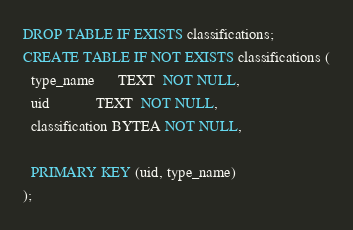<code> <loc_0><loc_0><loc_500><loc_500><_SQL_>DROP TABLE IF EXISTS classifications;
CREATE TABLE IF NOT EXISTS classifications (
  type_name      TEXT  NOT NULL,
  uid            TEXT  NOT NULL,
  classification BYTEA NOT NULL,

  PRIMARY KEY (uid, type_name)
);
</code> 